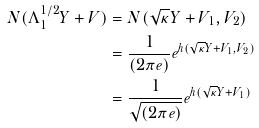<formula> <loc_0><loc_0><loc_500><loc_500>N ( \Lambda _ { 1 } ^ { 1 / 2 } Y + V ) & = N ( \sqrt { \kappa } Y + V _ { 1 } , V _ { 2 } ) \\ & = \frac { 1 } { ( 2 \pi e ) } e ^ { h ( \sqrt { \kappa } Y + V _ { 1 } , V _ { 2 } ) } \\ & = \frac { 1 } { \sqrt { ( 2 \pi e ) } } e ^ { h ( \sqrt { \kappa } Y + V _ { 1 } ) }</formula> 